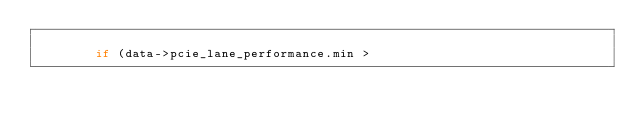Convert code to text. <code><loc_0><loc_0><loc_500><loc_500><_C_>
				if (data->pcie_lane_performance.min ></code> 